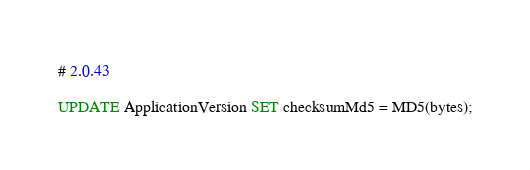Convert code to text. <code><loc_0><loc_0><loc_500><loc_500><_SQL_># 2.0.43

UPDATE ApplicationVersion SET checksumMd5 = MD5(bytes);
</code> 